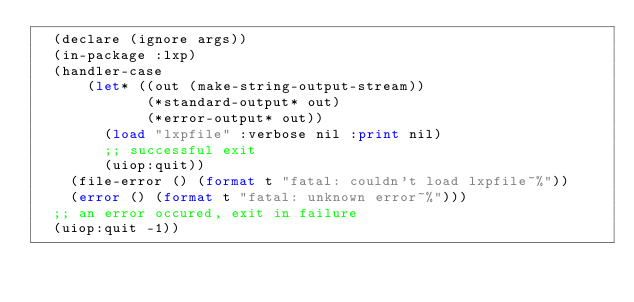<code> <loc_0><loc_0><loc_500><loc_500><_Lisp_>  (declare (ignore args))
  (in-package :lxp)
  (handler-case
      (let* ((out (make-string-output-stream))
             (*standard-output* out)
             (*error-output* out))
        (load "lxpfile" :verbose nil :print nil)
        ;; successful exit
        (uiop:quit))
    (file-error () (format t "fatal: couldn't load lxpfile~%"))
    (error () (format t "fatal: unknown error~%")))
  ;; an error occured, exit in failure
  (uiop:quit -1))
</code> 